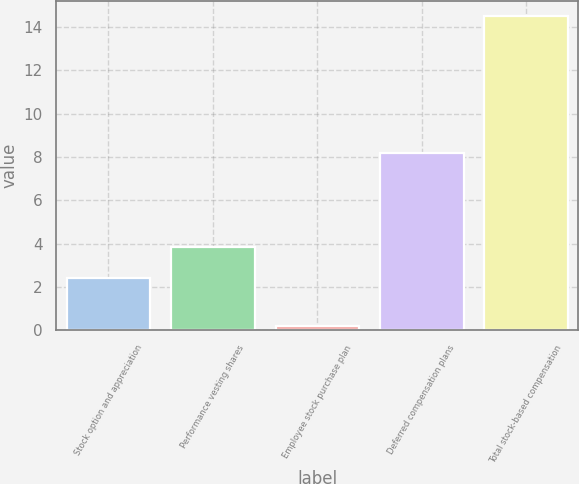<chart> <loc_0><loc_0><loc_500><loc_500><bar_chart><fcel>Stock option and appreciation<fcel>Performance vesting shares<fcel>Employee stock purchase plan<fcel>Deferred compensation plans<fcel>Total stock-based compensation<nl><fcel>2.4<fcel>3.83<fcel>0.2<fcel>8.2<fcel>14.5<nl></chart> 